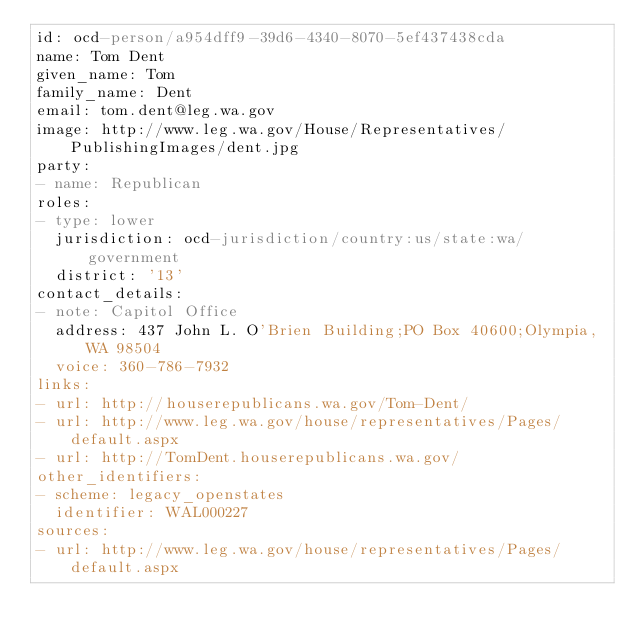Convert code to text. <code><loc_0><loc_0><loc_500><loc_500><_YAML_>id: ocd-person/a954dff9-39d6-4340-8070-5ef437438cda
name: Tom Dent
given_name: Tom
family_name: Dent
email: tom.dent@leg.wa.gov
image: http://www.leg.wa.gov/House/Representatives/PublishingImages/dent.jpg
party:
- name: Republican
roles:
- type: lower
  jurisdiction: ocd-jurisdiction/country:us/state:wa/government
  district: '13'
contact_details:
- note: Capitol Office
  address: 437 John L. O'Brien Building;PO Box 40600;Olympia, WA 98504
  voice: 360-786-7932
links:
- url: http://houserepublicans.wa.gov/Tom-Dent/
- url: http://www.leg.wa.gov/house/representatives/Pages/default.aspx
- url: http://TomDent.houserepublicans.wa.gov/
other_identifiers:
- scheme: legacy_openstates
  identifier: WAL000227
sources:
- url: http://www.leg.wa.gov/house/representatives/Pages/default.aspx
</code> 